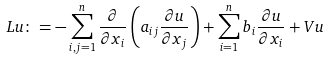<formula> <loc_0><loc_0><loc_500><loc_500>L u \colon = - \sum _ { i , j = 1 } ^ { n } \frac { \partial } { \partial x _ { i } } \left ( a _ { i j } \frac { \partial u } { \partial x _ { j } } \right ) + \sum _ { i = 1 } ^ { n } b _ { i } \frac { \partial u } { \partial x _ { i } } + V u</formula> 